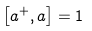<formula> <loc_0><loc_0><loc_500><loc_500>\left [ a ^ { + } , a \right ] = 1</formula> 